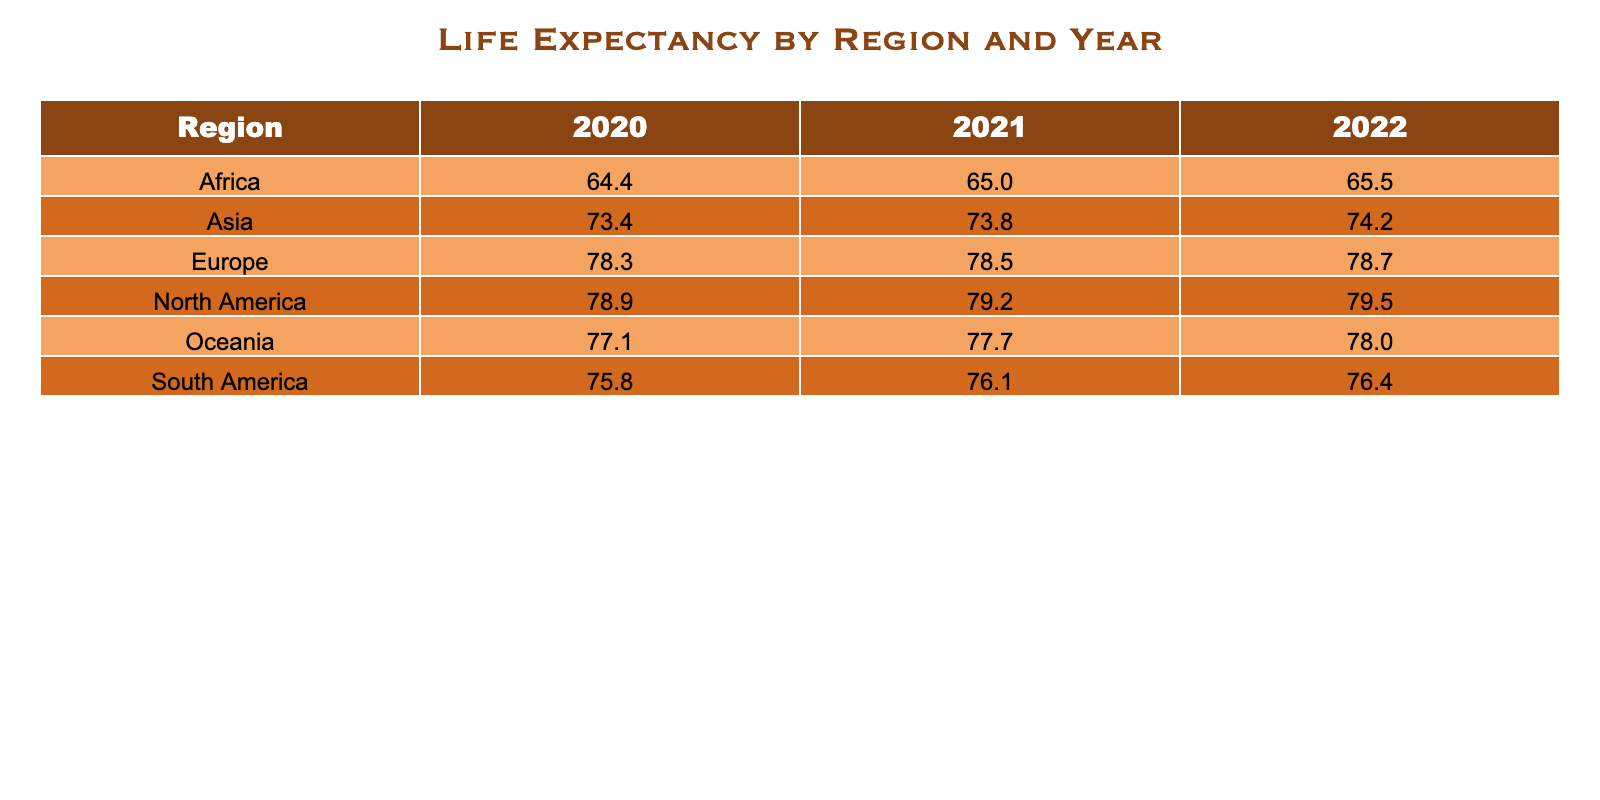What was the life expectancy in North America in 2021? Referring to the table, the life expectancy for North America in 2021 is specifically listed under that year. Checking the corresponding cell reveals the value is 79.2 years.
Answer: 79.2 years Which region had the highest life expectancy in 2022? To find this, I compare the life expectancy values for all regions in 2022. North America has 79.5, Europe has 78.7, Asia has 74.2, Africa has 65.5, Oceania has 78.0, and South America has 76.4 years. North America has the highest value.
Answer: North America What is the difference in life expectancy between Africa in 2020 and the average life expectancy in the same year for all regions? The life expectancy for Africa in 2020 is 64.4. The average life expectancy for all regions in 2020 is calculated by adding all values (78.9 + 78.3 + 73.4 + 64.4 + 77.1 + 75.8) and dividing by the number of regions (6), which is approximately 74.3. The difference is 74.3 - 64.4 = 9.9 years.
Answer: 9.9 years Is the life expectancy in Oceania higher in 2021 than in Europe in the same year? I check the values for Oceania in 2021 (77.7) and Europe in 2021 (78.5). Since 77.7 is less than 78.5, the statement is false.
Answer: No What is the average life expectancy across all regions for the year 2022? To calculate this, I need to add the life expectancy values for each region in 2022: North America (79.5) + Europe (78.7) + Asia (74.2) + Africa (65.5) + Oceania (78.0) + South America (76.4) = 452.3. Then I divide this sum by 6 (the number of regions), giving an average of approximately 75.38 years.
Answer: 75.38 years What is the life expectancy for South America in 2021, and how does it compare to that of Asia in the same year? From the table, South America in 2021 has a life expectancy of 76.1, while Asia has 73.8. Comparing these values shows that 76.1 is greater than 73.8, indicating South America has a higher life expectancy than Asia in 2021.
Answer: South America is higher than Asia Which region showed the smallest increase in life expectancy from 2020 to 2021? I examine the increases for each region: North America (0.3), Europe (0.2), Asia (0.4), Africa (0.6), Oceania (0.6), and South America (0.3). The smallest increase is 0.2 years for Europe.
Answer: Europe How many regions have a life expectancy below 70 years in 2022? Checking the table for 2022, Asia (74.2), Africa (65.5), North America (79.5), Europe (78.7), Oceania (78.0), and South America (76.4) reveals that only Africa has a life expectancy below 70. Therefore, only one region meets this criterion.
Answer: One region 